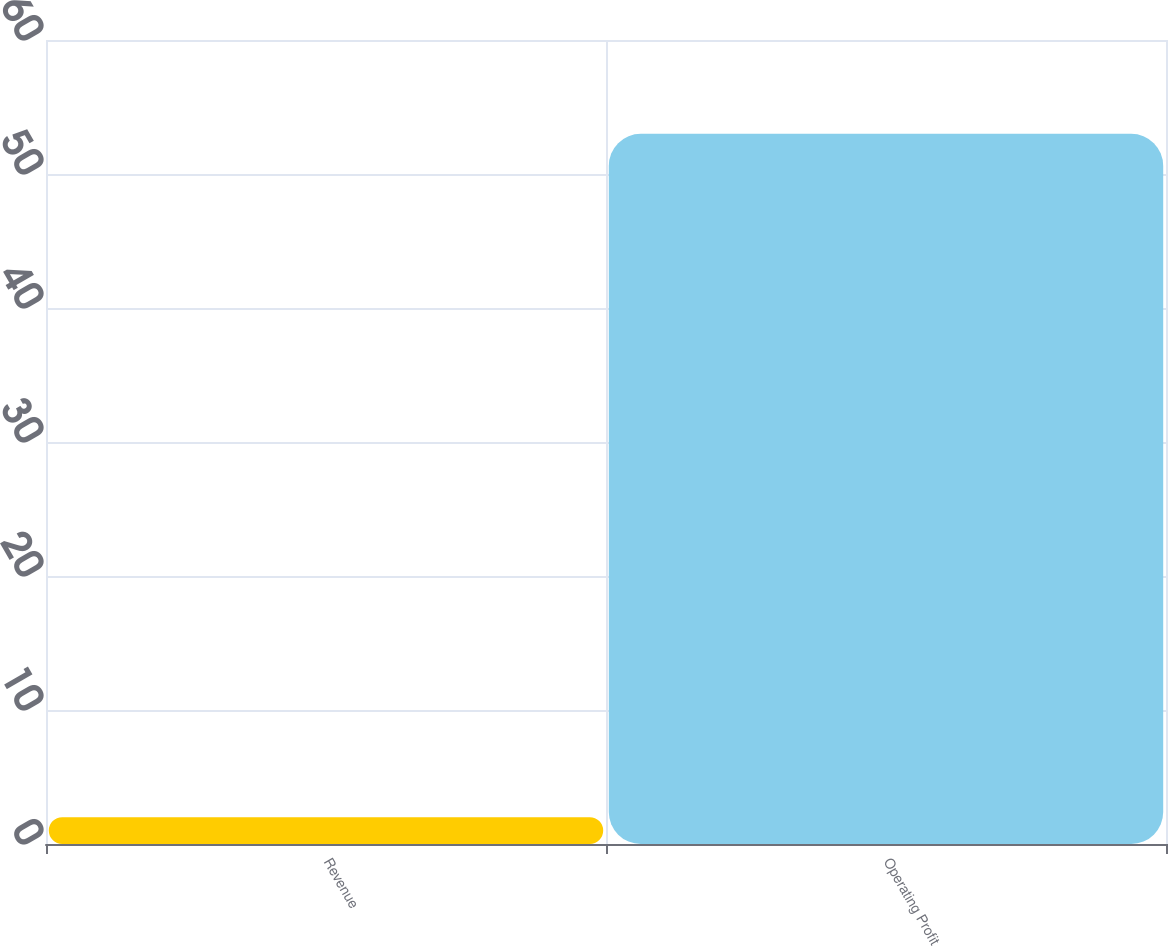Convert chart. <chart><loc_0><loc_0><loc_500><loc_500><bar_chart><fcel>Revenue<fcel>Operating Profit<nl><fcel>2<fcel>53<nl></chart> 